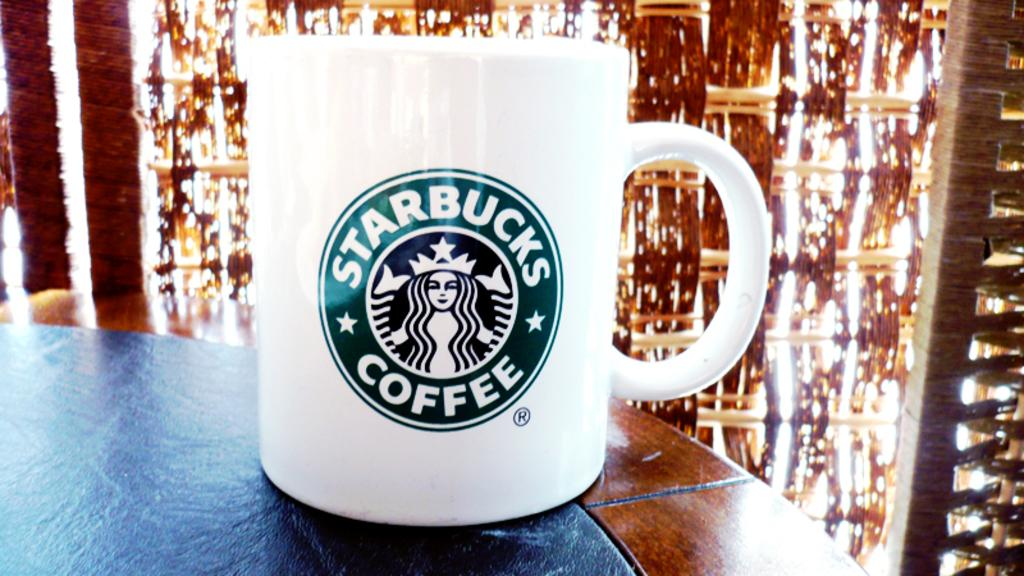<image>
Render a clear and concise summary of the photo. a cup that has the word coffee on it 